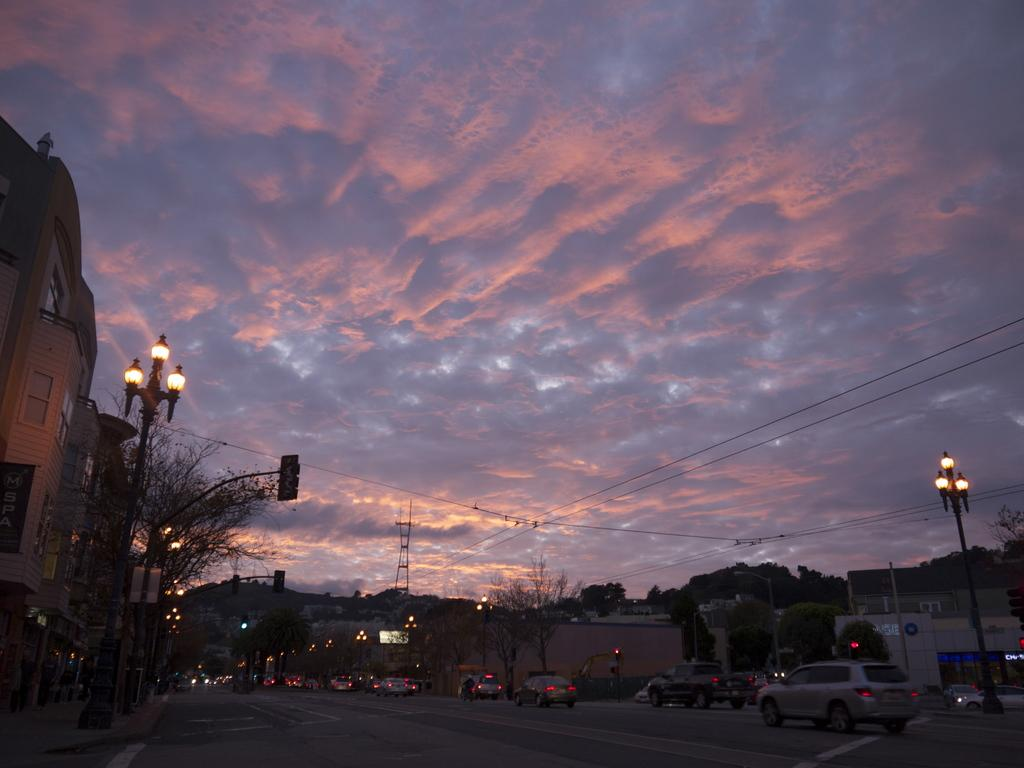What can be seen on the road in the image? There are vehicles on the road in the image. What is attached to the poles in the image? Lights and traffic signals are attached to the poles in the image. What type of structures can be seen in the image? Buildings are visible in the image. What is present in the background of the image? Trees are present in the background of the image. What is visible in the sky in the image? The sky is visible with clouds in the image. What else can be observed in the image? Wires are observable in the image. Where is the bottle of honey being used in the image? There is no bottle of honey present in the image. What type of health benefits can be observed from the image? The image does not depict any health-related information or benefits. 